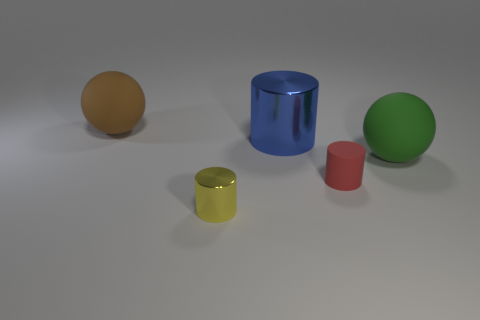What is the shape of the shiny thing that is behind the sphere that is in front of the large brown object?
Offer a very short reply. Cylinder. Do the big metal cylinder and the tiny metallic object have the same color?
Your answer should be very brief. No. How many cubes are big green matte things or small yellow objects?
Keep it short and to the point. 0. There is a thing that is both to the right of the small yellow thing and behind the large green rubber sphere; what material is it?
Your answer should be compact. Metal. What number of spheres are left of the yellow cylinder?
Your answer should be very brief. 1. Is the large ball that is behind the blue metal cylinder made of the same material as the cylinder that is left of the blue shiny thing?
Offer a terse response. No. How many things are cylinders left of the large blue shiny thing or small yellow spheres?
Keep it short and to the point. 1. Is the number of small cylinders left of the large blue thing less than the number of big matte things on the left side of the yellow thing?
Keep it short and to the point. No. How many other objects are there of the same size as the red thing?
Provide a succinct answer. 1. Is the large brown thing made of the same material as the tiny cylinder that is to the right of the large cylinder?
Ensure brevity in your answer.  Yes. 